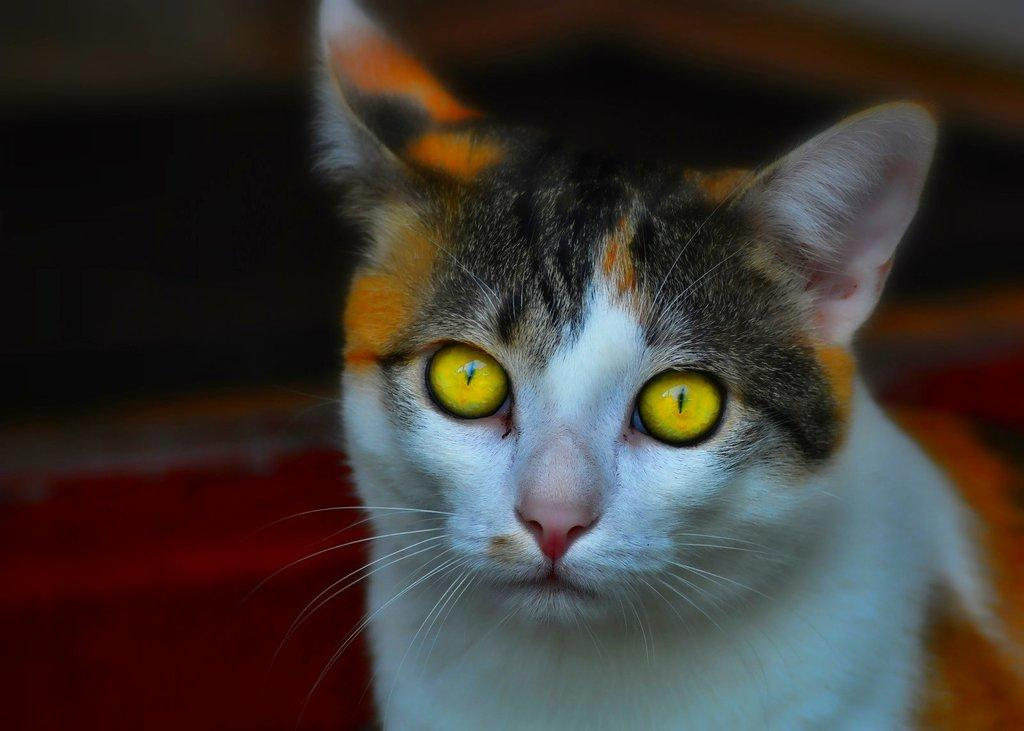What type of animal is in the image? There is a cat in the image. Can you describe the background of the image? The background of the image is blurred. What type of toys can be seen in the image? There are no toys present in the image; it features a cat and a blurred background. 